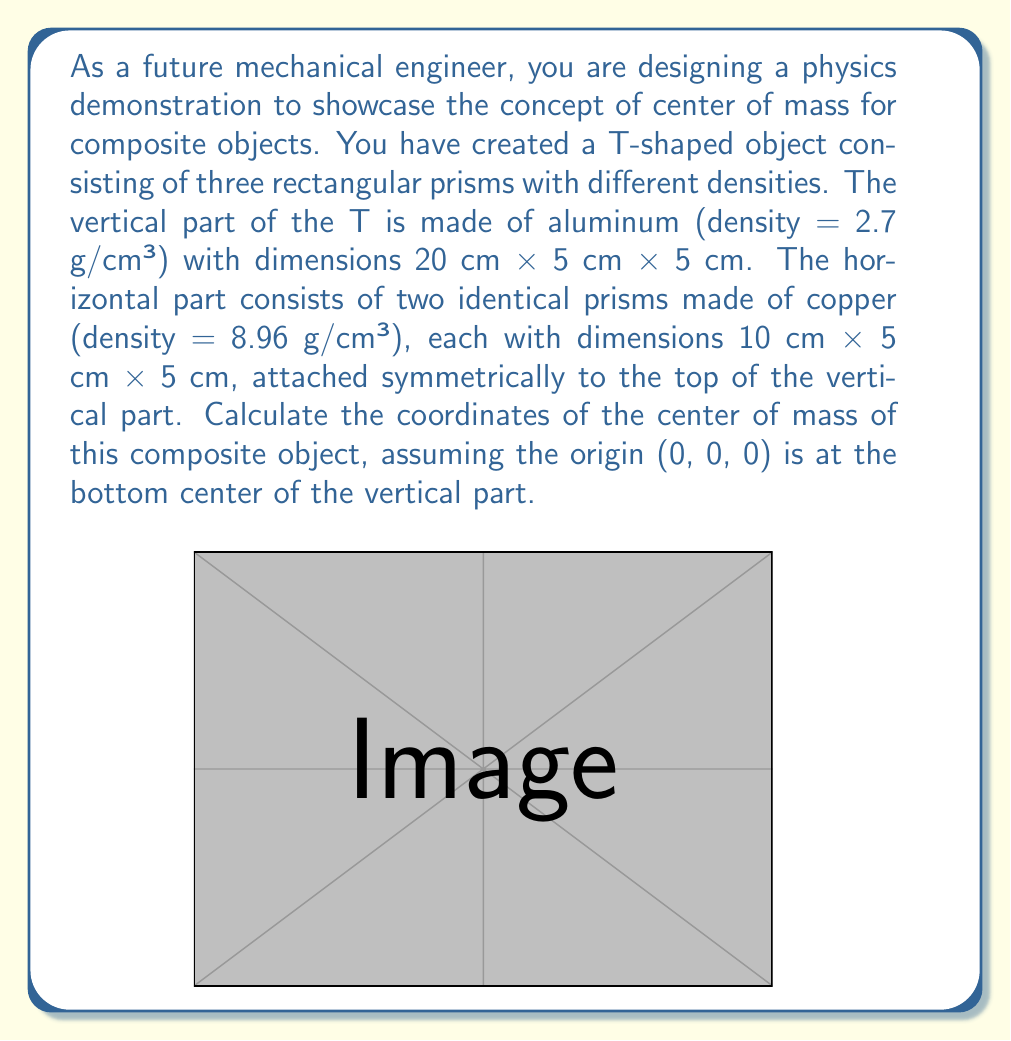Give your solution to this math problem. To solve this problem, we'll follow these steps:

1) Calculate the mass of each component:
   - Aluminum part: $m_{Al} = 2.7 \text{ g/cm³} \times (20 \text{ cm} \times 5 \text{ cm} \times 5 \text{ cm}) = 1350 \text{ g}$
   - Each Copper part: $m_{Cu} = 8.96 \text{ g/cm³} \times (10 \text{ cm} \times 5 \text{ cm} \times 5 \text{ cm}) = 2240 \text{ g}$
   - Total mass: $m_{total} = 1350 \text{ g} + 2(2240 \text{ g}) = 5830 \text{ g}$

2) Find the center of mass of each component:
   - Aluminum: $(0, 2.5, 10)$ cm
   - Left Copper: $(-5, 2.5, 22.5)$ cm
   - Right Copper: $(5, 2.5, 22.5)$ cm

3) Use the formula for center of mass of a composite object:
   $$\vec{r}_{cm} = \frac{\sum_i m_i \vec{r}_i}{\sum_i m_i}$$

   Where $\vec{r}_{cm}$ is the position vector of the center of mass, $m_i$ is the mass of each component, and $\vec{r}_i$ is the position vector of each component's center of mass.

4) Calculate each coordinate separately:

   x-coordinate:
   $$x_{cm} = \frac{1350(0) + 2240(-5) + 2240(5)}{5830} = 0 \text{ cm}$$

   y-coordinate:
   $$y_{cm} = \frac{1350(2.5) + 2240(2.5) + 2240(2.5)}{5830} = 2.5 \text{ cm}$$

   z-coordinate:
   $$z_{cm} = \frac{1350(10) + 2240(22.5) + 2240(22.5)}{5830} \approx 19.23 \text{ cm}$$

Therefore, the center of mass of the composite object is at (0, 2.5, 19.23) cm.
Answer: The center of mass of the composite object is at $(0, 2.5, 19.23)$ cm. 